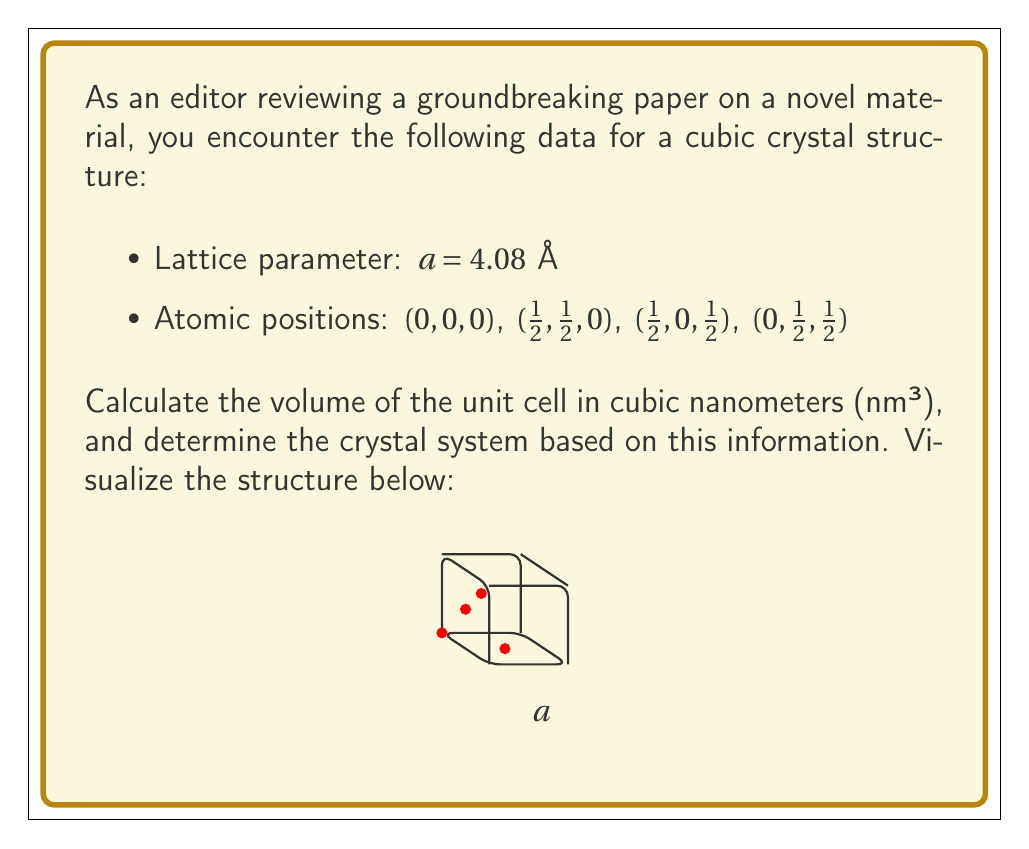Could you help me with this problem? To solve this problem, we'll follow these steps:

1) Calculate the volume of the unit cell:
   For a cubic crystal, the volume $V$ is given by $V = a^3$, where $a$ is the lattice parameter.
   
   $V = (4.08 \AA)^3 = 67.8551 \AA^3$

2) Convert the volume from $\AA^3$ to nm³:
   $1 \AA = 0.1$ nm, so $1 \AA^3 = (0.1$ nm$)^3 = 0.001$ nm³
   
   $67.8551 \AA^3 \times 0.001$ nm³/$\AA^3 = 0.0678551$ nm³

3) Determine the crystal system:
   The lattice parameter $a$ is the same for all dimensions, and the atomic positions are at (0,0,0) and the face centers ($\frac{1}{2}$,$\frac{1}{2}$,0), ($\frac{1}{2}$,0,$\frac{1}{2}$), (0,$\frac{1}{2}$,$\frac{1}{2}$). This arrangement corresponds to a face-centered cubic (FCC) crystal structure, which belongs to the cubic crystal system.

The visualization provided in the question shows the unit cell of an FCC structure, with atoms at the corners and face centers of the cube.
Answer: $0.0678551$ nm³; Face-centered cubic (FCC) 